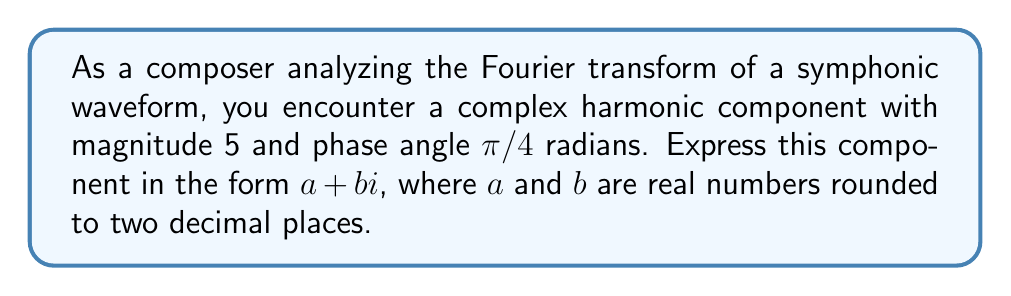Show me your answer to this math problem. To solve this problem, we'll follow these steps:

1) The Fourier transform represents a signal as a sum of complex exponentials. Each component can be expressed in polar form as $r e^{i\theta}$, where $r$ is the magnitude and $\theta$ is the phase angle.

2) In this case, we have:
   $r = 5$ (magnitude)
   $\theta = \frac{\pi}{4}$ (phase angle)

3) To convert from polar form to rectangular form $(a + bi)$, we use Euler's formula:
   $r e^{i\theta} = r(\cos\theta + i\sin\theta)$

4) Substituting our values:
   $5 e^{i\frac{\pi}{4}} = 5(\cos\frac{\pi}{4} + i\sin\frac{\pi}{4})$

5) We know that:
   $\cos\frac{\pi}{4} = \sin\frac{\pi}{4} = \frac{\sqrt{2}}{2}$

6) Substituting these values:
   $5 e^{i\frac{\pi}{4}} = 5(\frac{\sqrt{2}}{2} + i\frac{\sqrt{2}}{2})$

7) Simplifying:
   $5 e^{i\frac{\pi}{4}} = \frac{5\sqrt{2}}{2} + i\frac{5\sqrt{2}}{2}$

8) Calculate the decimal approximations:
   $\frac{5\sqrt{2}}{2} \approx 3.5355$

9) Rounding to two decimal places:
   $a \approx 3.54$
   $b \approx 3.54$

Therefore, the complex harmonic component can be expressed as approximately $3.54 + 3.54i$.
Answer: $3.54 + 3.54i$ 